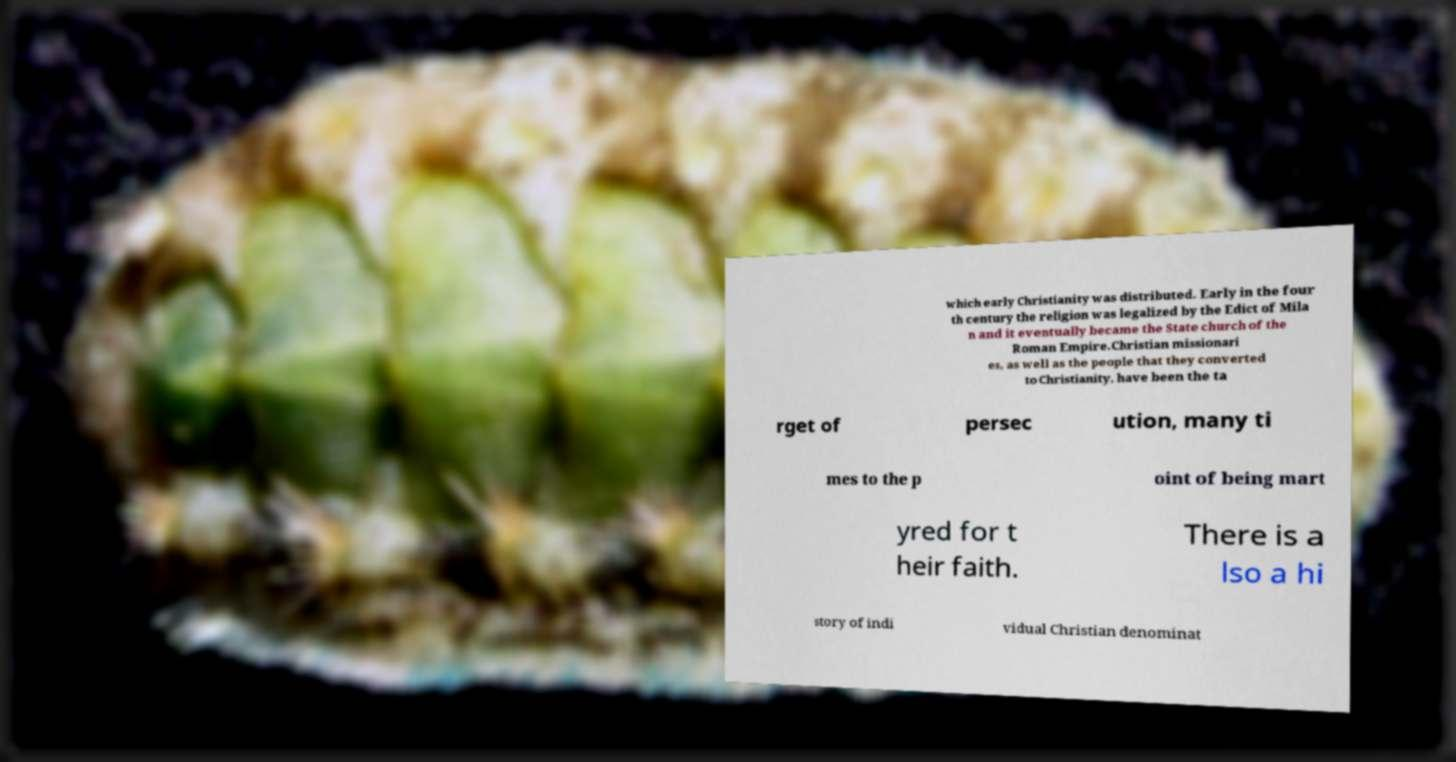Please identify and transcribe the text found in this image. which early Christianity was distributed. Early in the four th century the religion was legalized by the Edict of Mila n and it eventually became the State church of the Roman Empire.Christian missionari es, as well as the people that they converted to Christianity, have been the ta rget of persec ution, many ti mes to the p oint of being mart yred for t heir faith. There is a lso a hi story of indi vidual Christian denominat 